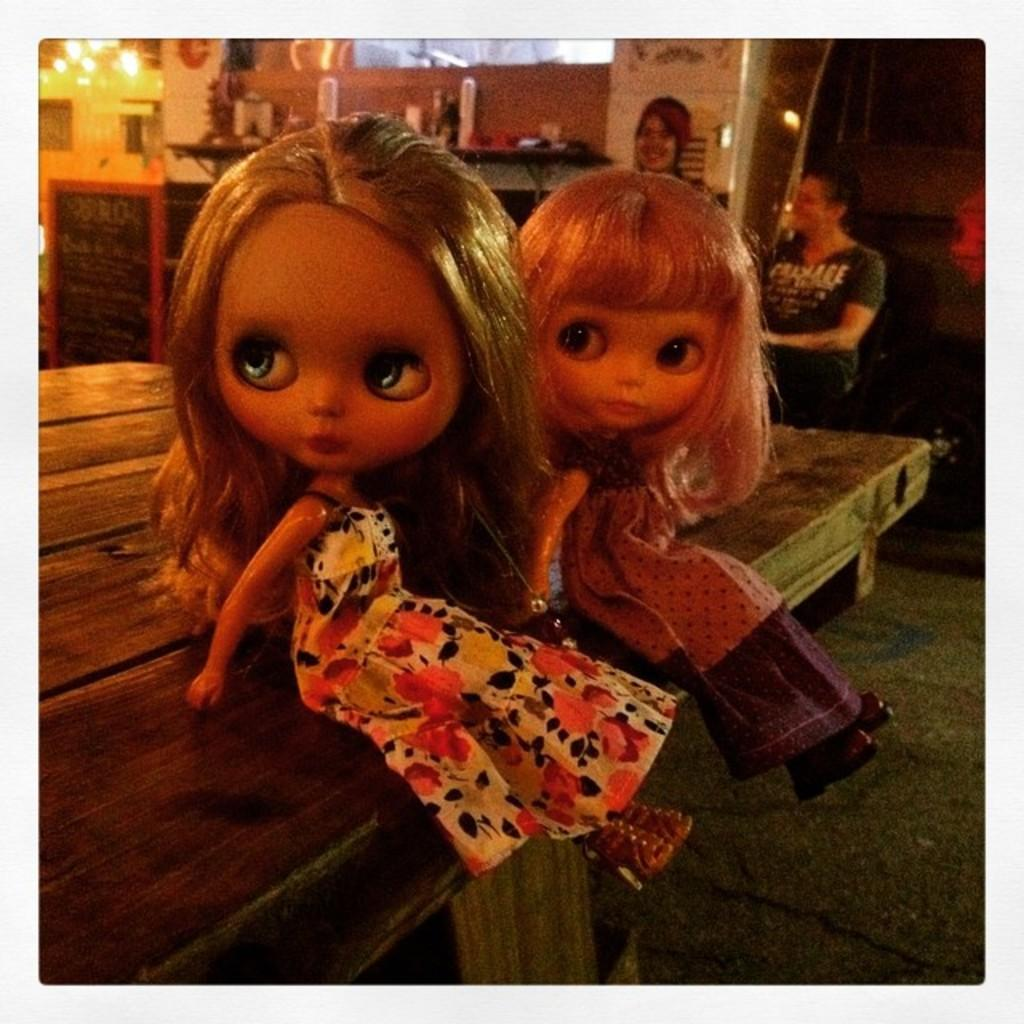What objects are on the table in the image? There are two dolls on a table in the image. What can be seen on the board in the image? The facts provided do not specify what is on the board, so we cannot answer that question definitively. What type of lighting is present in the image? There are lights in the image. How many people are visible in the image? There are people standing in the image. What can be seen in the background of the image? There are objects visible in the background of the image. What is the value of the hospital in the image? There is no hospital present in the image, so we cannot determine its value. What specific detail can be seen on the dolls' clothing in the image? The facts provided do not specify any details about the dolls' clothing, so we cannot answer that question definitively. 